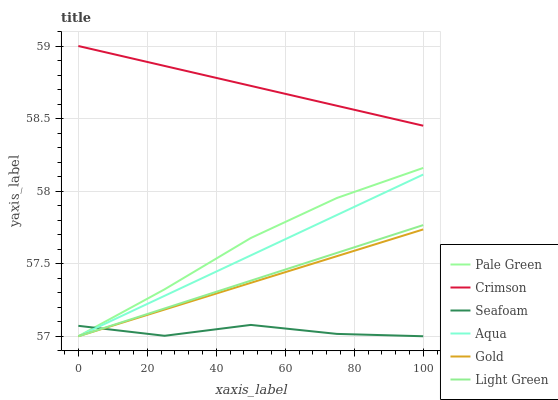Does Seafoam have the minimum area under the curve?
Answer yes or no. Yes. Does Crimson have the maximum area under the curve?
Answer yes or no. Yes. Does Aqua have the minimum area under the curve?
Answer yes or no. No. Does Aqua have the maximum area under the curve?
Answer yes or no. No. Is Aqua the smoothest?
Answer yes or no. Yes. Is Seafoam the roughest?
Answer yes or no. Yes. Is Seafoam the smoothest?
Answer yes or no. No. Is Aqua the roughest?
Answer yes or no. No. Does Gold have the lowest value?
Answer yes or no. Yes. Does Crimson have the lowest value?
Answer yes or no. No. Does Crimson have the highest value?
Answer yes or no. Yes. Does Aqua have the highest value?
Answer yes or no. No. Is Gold less than Crimson?
Answer yes or no. Yes. Is Crimson greater than Light Green?
Answer yes or no. Yes. Does Gold intersect Light Green?
Answer yes or no. Yes. Is Gold less than Light Green?
Answer yes or no. No. Is Gold greater than Light Green?
Answer yes or no. No. Does Gold intersect Crimson?
Answer yes or no. No. 